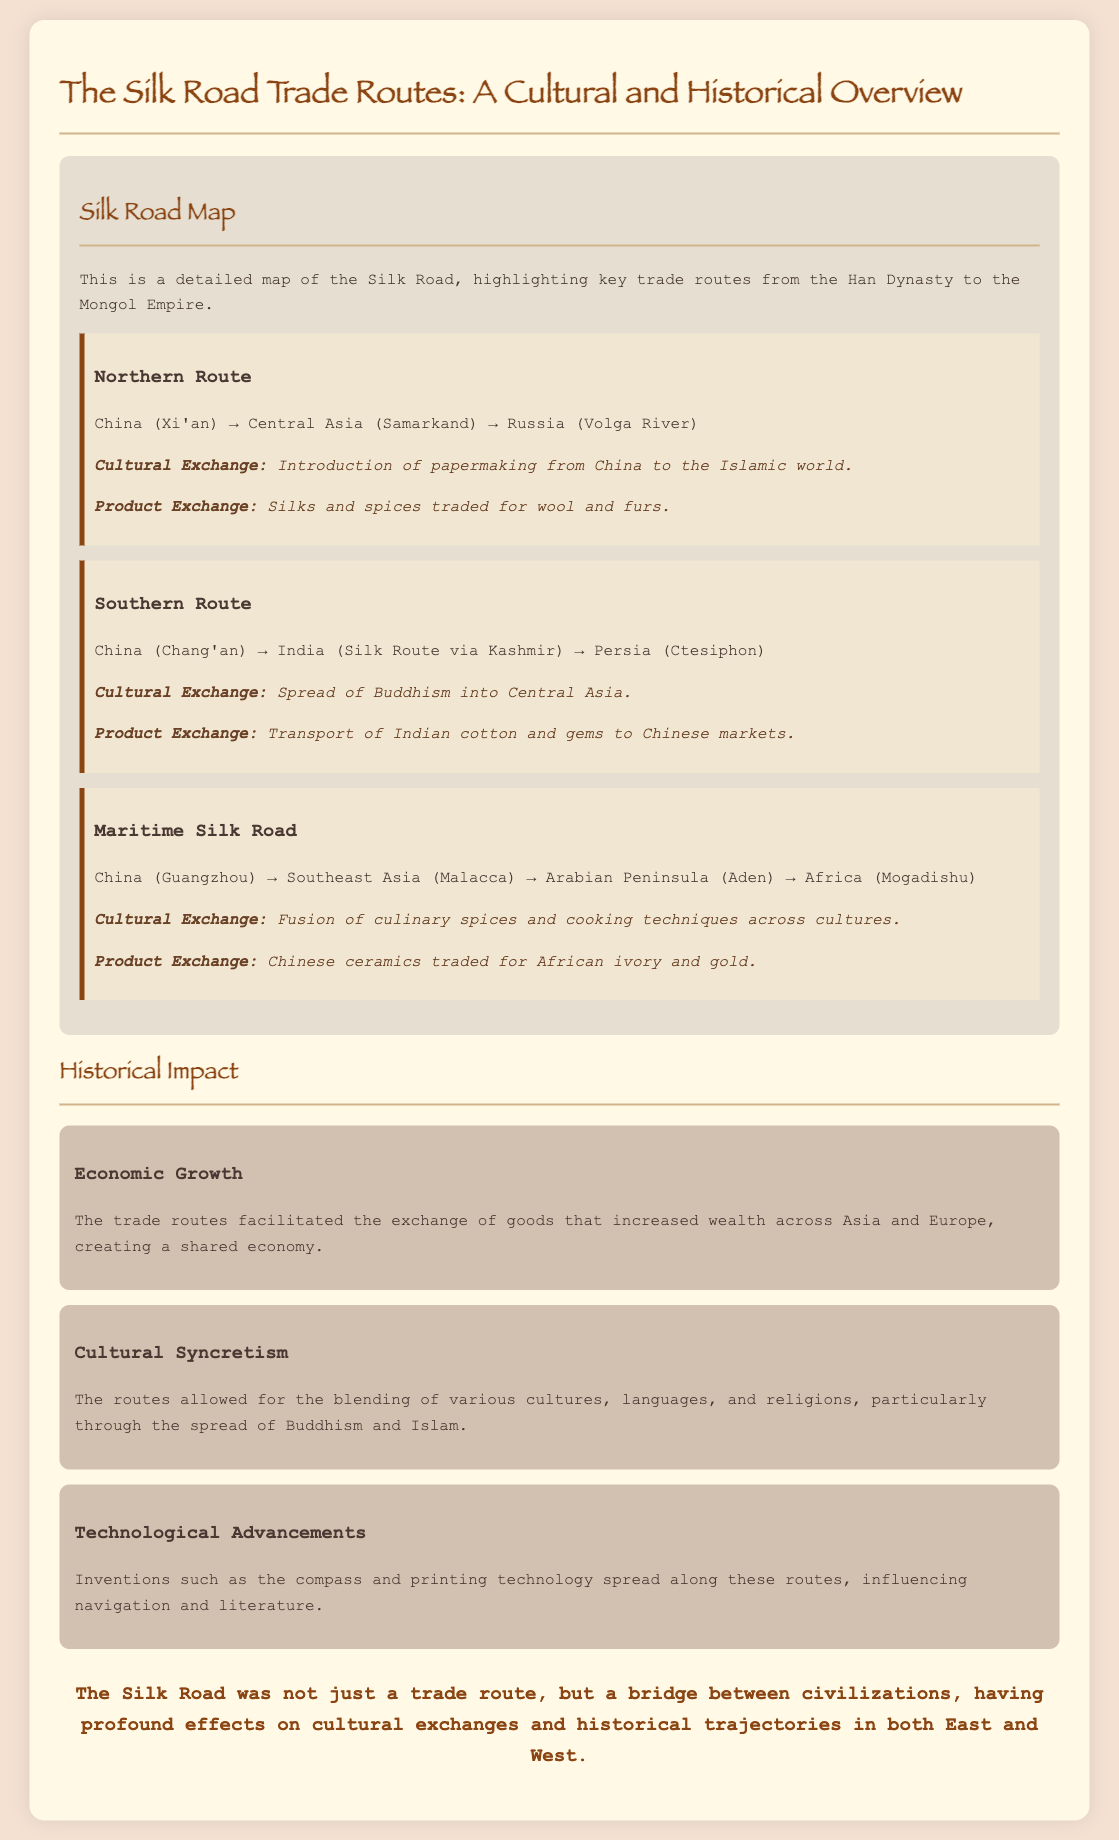what is the title of the document? The title of the document can be found at the top of the rendered document, which is "The Silk Road Trade Routes: A Cultural and Historical Overview."
Answer: The Silk Road Trade Routes: A Cultural and Historical Overview which empire is referenced at the beginning of the trade route section? The first trade route mentioned links to China during the Han Dynasty.
Answer: Han Dynasty what were the products exchanged along the Northern Route? The document lists specific products exchanged, which are silks and spices traded for wool and furs.
Answer: Silks and spices for wool and furs how many main trade routes are highlighted in the document? The document outlines three distinct trade routes in the map section.
Answer: Three what cultural exchange is associated with the Southern Route? The cultural exchange highlighted in the Southern Route is the spread of Buddhism into Central Asia.
Answer: Spread of Buddhism what is one of the technological advancements mentioned? The document specifies inventions spread along the trade routes, one being the compass.
Answer: Compass how does the document describe the economic impact of the trade routes? The document describes the routes as facilitating exchange of goods that increased wealth across Asia and Europe.
Answer: Increased wealth what is the conclusion section stating about the Silk Road? The conclusion emphasizes the Silk Road's role as a bridge between civilizations with profound effects.
Answer: A bridge between civilizations 